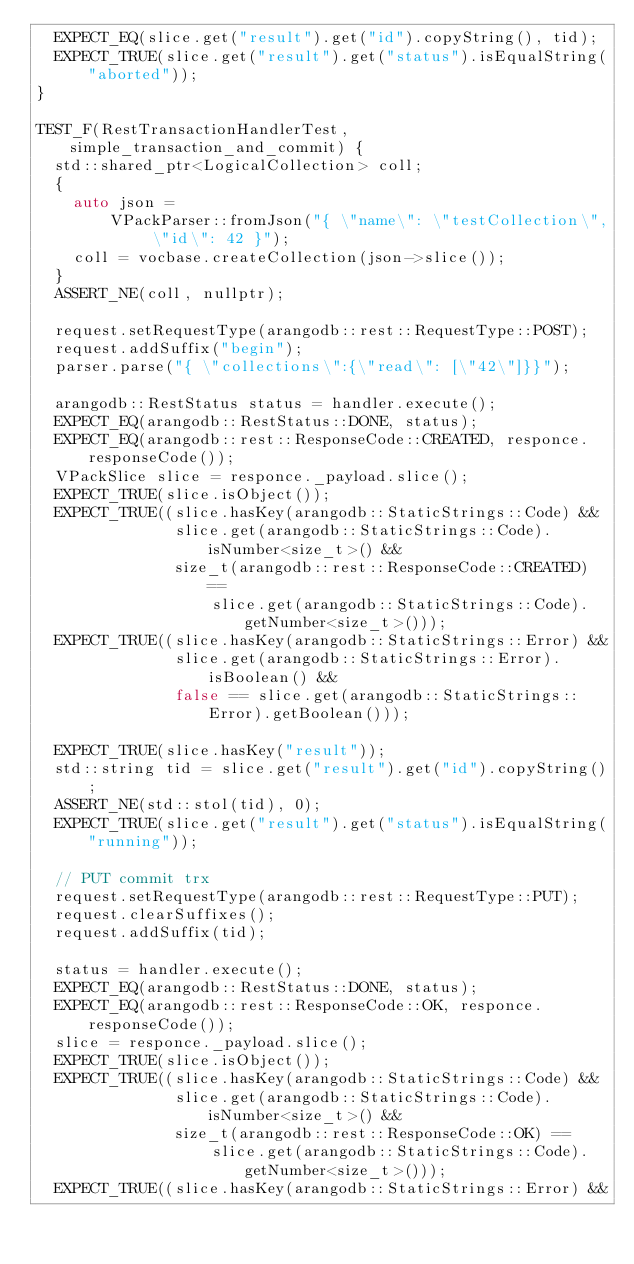Convert code to text. <code><loc_0><loc_0><loc_500><loc_500><_C++_>  EXPECT_EQ(slice.get("result").get("id").copyString(), tid);
  EXPECT_TRUE(slice.get("result").get("status").isEqualString("aborted"));
}

TEST_F(RestTransactionHandlerTest, simple_transaction_and_commit) {
  std::shared_ptr<LogicalCollection> coll;
  {
    auto json =
        VPackParser::fromJson("{ \"name\": \"testCollection\", \"id\": 42 }");
    coll = vocbase.createCollection(json->slice());
  }
  ASSERT_NE(coll, nullptr);

  request.setRequestType(arangodb::rest::RequestType::POST);
  request.addSuffix("begin");
  parser.parse("{ \"collections\":{\"read\": [\"42\"]}}");

  arangodb::RestStatus status = handler.execute();
  EXPECT_EQ(arangodb::RestStatus::DONE, status);
  EXPECT_EQ(arangodb::rest::ResponseCode::CREATED, responce.responseCode());
  VPackSlice slice = responce._payload.slice();
  EXPECT_TRUE(slice.isObject());
  EXPECT_TRUE((slice.hasKey(arangodb::StaticStrings::Code) &&
               slice.get(arangodb::StaticStrings::Code).isNumber<size_t>() &&
               size_t(arangodb::rest::ResponseCode::CREATED) ==
                   slice.get(arangodb::StaticStrings::Code).getNumber<size_t>()));
  EXPECT_TRUE((slice.hasKey(arangodb::StaticStrings::Error) &&
               slice.get(arangodb::StaticStrings::Error).isBoolean() &&
               false == slice.get(arangodb::StaticStrings::Error).getBoolean()));

  EXPECT_TRUE(slice.hasKey("result"));
  std::string tid = slice.get("result").get("id").copyString();
  ASSERT_NE(std::stol(tid), 0);
  EXPECT_TRUE(slice.get("result").get("status").isEqualString("running"));

  // PUT commit trx
  request.setRequestType(arangodb::rest::RequestType::PUT);
  request.clearSuffixes();
  request.addSuffix(tid);

  status = handler.execute();
  EXPECT_EQ(arangodb::RestStatus::DONE, status);
  EXPECT_EQ(arangodb::rest::ResponseCode::OK, responce.responseCode());
  slice = responce._payload.slice();
  EXPECT_TRUE(slice.isObject());
  EXPECT_TRUE((slice.hasKey(arangodb::StaticStrings::Code) &&
               slice.get(arangodb::StaticStrings::Code).isNumber<size_t>() &&
               size_t(arangodb::rest::ResponseCode::OK) ==
                   slice.get(arangodb::StaticStrings::Code).getNumber<size_t>()));
  EXPECT_TRUE((slice.hasKey(arangodb::StaticStrings::Error) &&</code> 